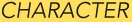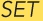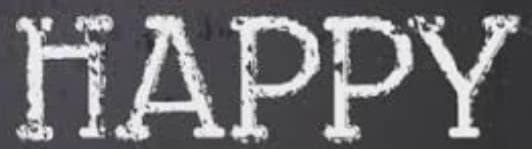What text appears in these images from left to right, separated by a semicolon? CHARACTER; SET; HAPPY 